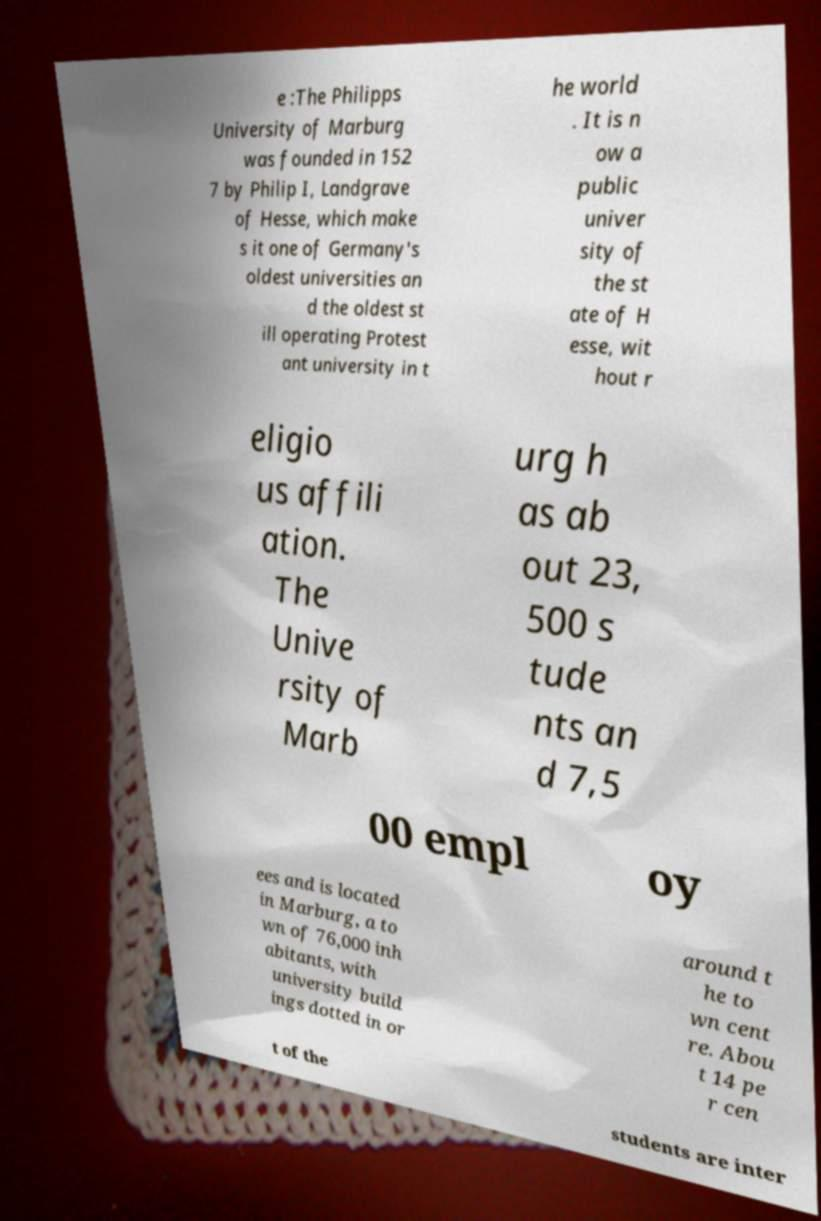Please read and relay the text visible in this image. What does it say? e :The Philipps University of Marburg was founded in 152 7 by Philip I, Landgrave of Hesse, which make s it one of Germany's oldest universities an d the oldest st ill operating Protest ant university in t he world . It is n ow a public univer sity of the st ate of H esse, wit hout r eligio us affili ation. The Unive rsity of Marb urg h as ab out 23, 500 s tude nts an d 7,5 00 empl oy ees and is located in Marburg, a to wn of 76,000 inh abitants, with university build ings dotted in or around t he to wn cent re. Abou t 14 pe r cen t of the students are inter 